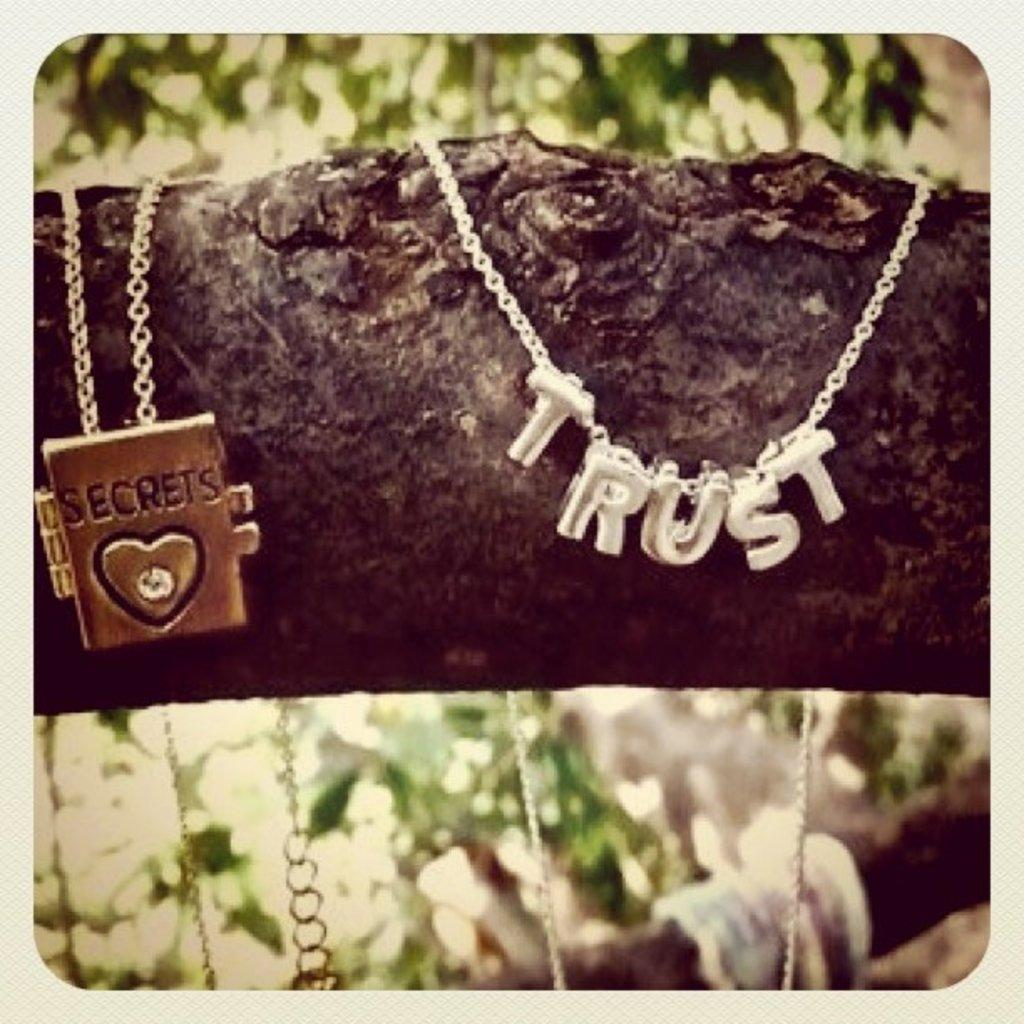<image>
Describe the image concisely. tree branch that has a two necklaces one has trust on it and the other has a book with word secrets on it 